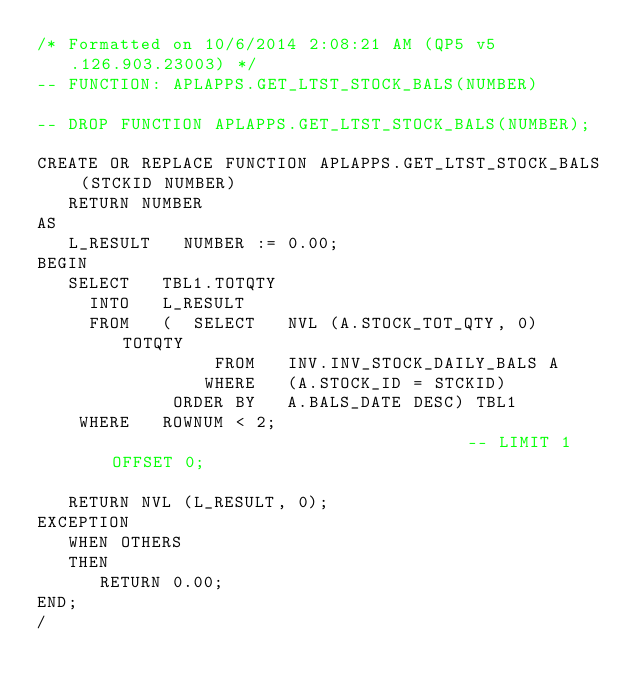<code> <loc_0><loc_0><loc_500><loc_500><_SQL_>/* Formatted on 10/6/2014 2:08:21 AM (QP5 v5.126.903.23003) */
-- FUNCTION: APLAPPS.GET_LTST_STOCK_BALS(NUMBER)

-- DROP FUNCTION APLAPPS.GET_LTST_STOCK_BALS(NUMBER);

CREATE OR REPLACE FUNCTION APLAPPS.GET_LTST_STOCK_BALS (STCKID NUMBER)
   RETURN NUMBER
AS
   L_RESULT   NUMBER := 0.00;
BEGIN
   SELECT   TBL1.TOTQTY
     INTO   L_RESULT
     FROM   (  SELECT   NVL (A.STOCK_TOT_QTY, 0) TOTQTY
                 FROM   INV.INV_STOCK_DAILY_BALS A
                WHERE   (A.STOCK_ID = STCKID)
             ORDER BY   A.BALS_DATE DESC) TBL1
    WHERE   ROWNUM < 2;                                   -- LIMIT 1 OFFSET 0;

   RETURN NVL (L_RESULT, 0);
EXCEPTION
   WHEN OTHERS
   THEN
      RETURN 0.00;
END;
/</code> 